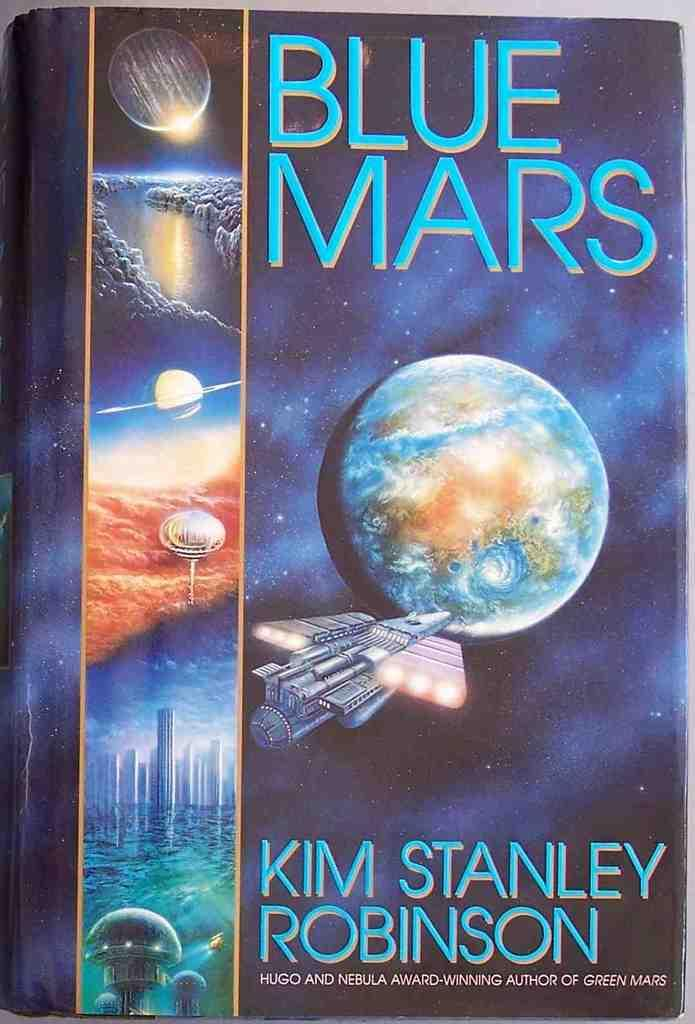<image>
Share a concise interpretation of the image provided. A book about space is called Blue Mars. 